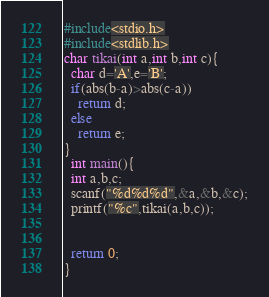Convert code to text. <code><loc_0><loc_0><loc_500><loc_500><_C_>#include<stdio.h>
#include<stdlib.h>
char tikai(int a,int b,int c){
  char d='A',e='B';
  if(abs(b-a)>abs(c-a))
    return d;
  else
    return e;
}
  int main(){
  int a,b,c;
  scanf("%d%d%d",&a,&b,&c);
  printf("%c",tikai(a,b,c));

    
  return 0;
}
</code> 